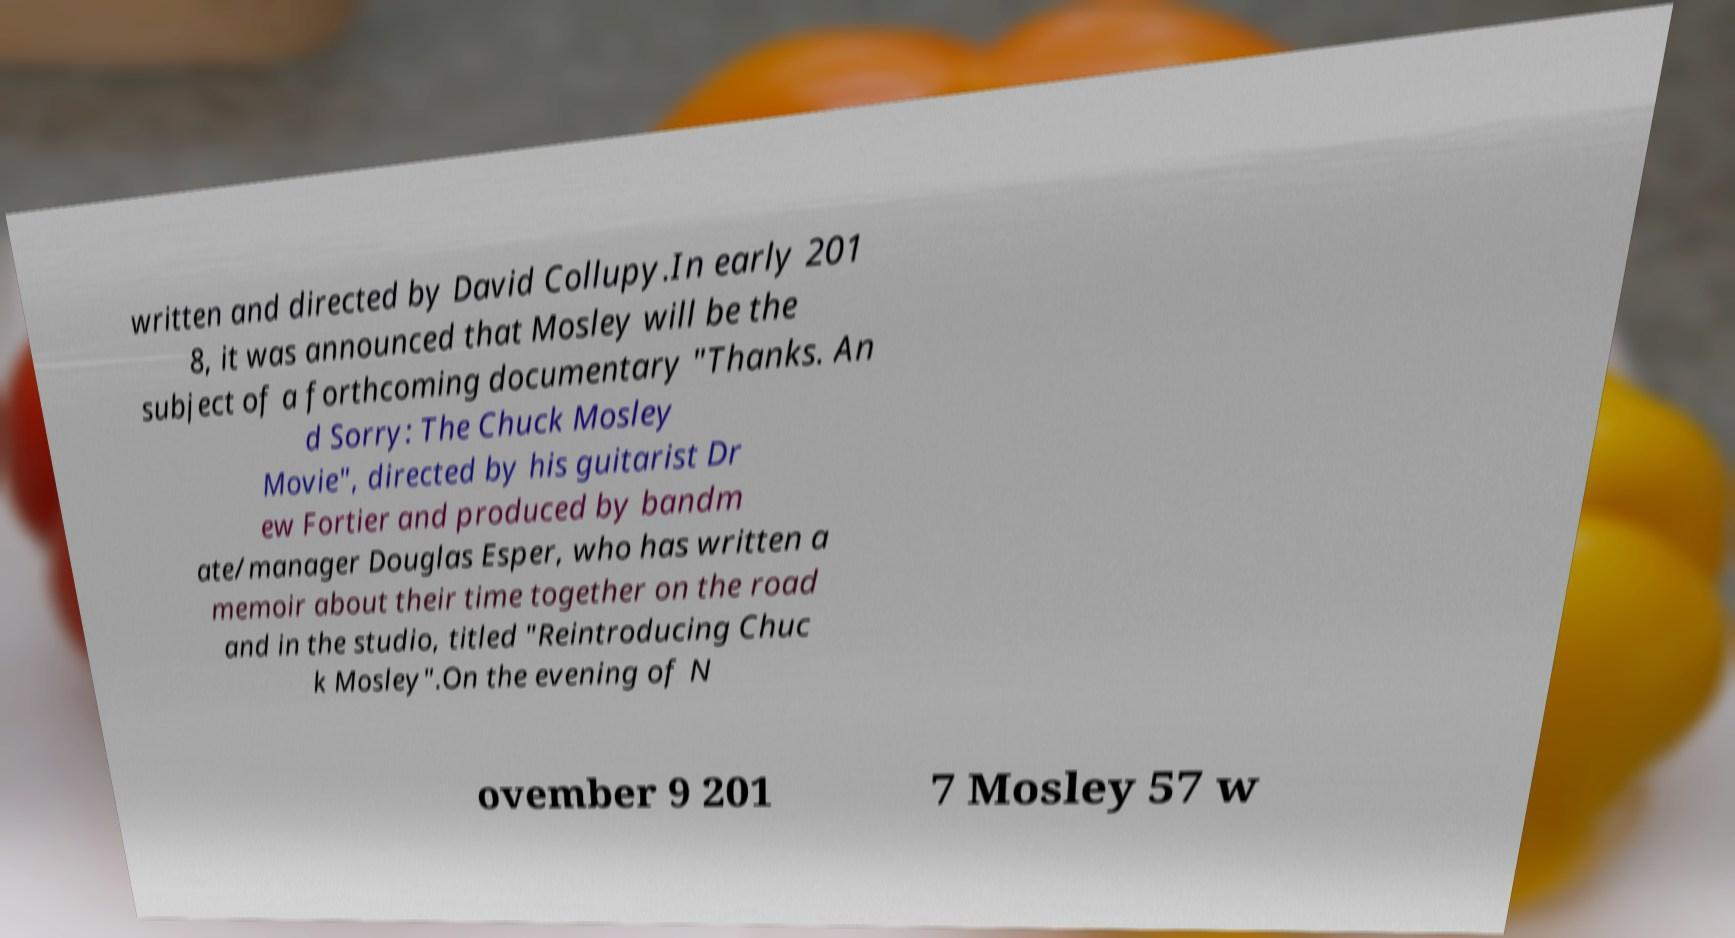Can you accurately transcribe the text from the provided image for me? written and directed by David Collupy.In early 201 8, it was announced that Mosley will be the subject of a forthcoming documentary "Thanks. An d Sorry: The Chuck Mosley Movie", directed by his guitarist Dr ew Fortier and produced by bandm ate/manager Douglas Esper, who has written a memoir about their time together on the road and in the studio, titled "Reintroducing Chuc k Mosley".On the evening of N ovember 9 201 7 Mosley 57 w 